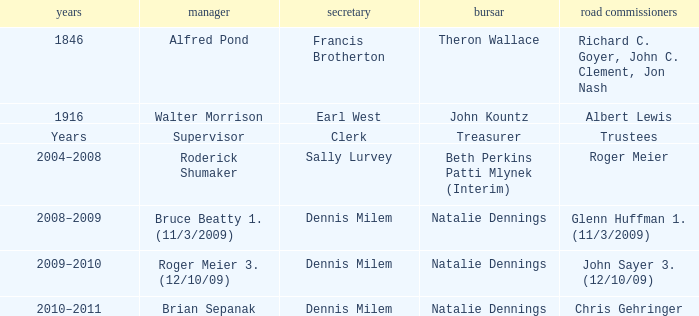When Treasurer was treasurer, who was the highway commissioner? Trustees. 